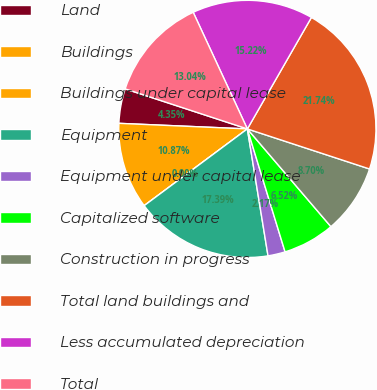Convert chart to OTSL. <chart><loc_0><loc_0><loc_500><loc_500><pie_chart><fcel>Land<fcel>Buildings<fcel>Buildings under capital lease<fcel>Equipment<fcel>Equipment under capital lease<fcel>Capitalized software<fcel>Construction in progress<fcel>Total land buildings and<fcel>Less accumulated depreciation<fcel>Total<nl><fcel>4.35%<fcel>10.87%<fcel>0.0%<fcel>17.39%<fcel>2.17%<fcel>6.52%<fcel>8.7%<fcel>21.74%<fcel>15.22%<fcel>13.04%<nl></chart> 